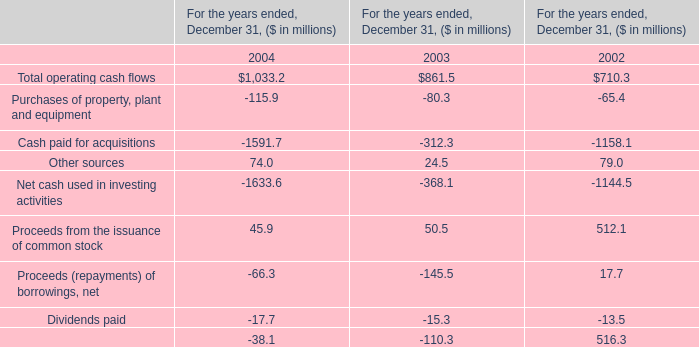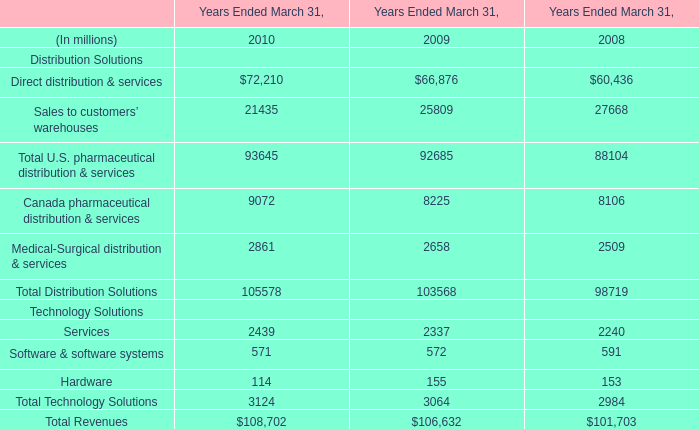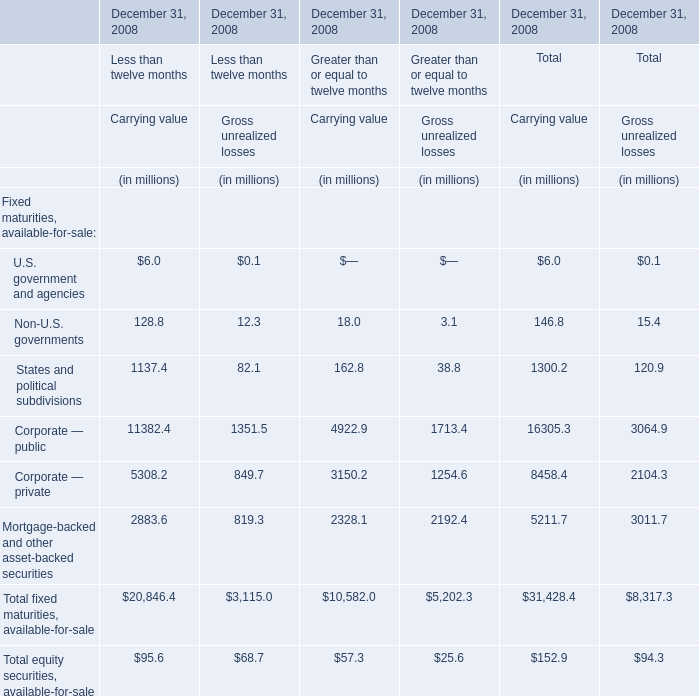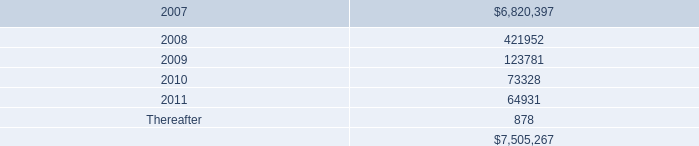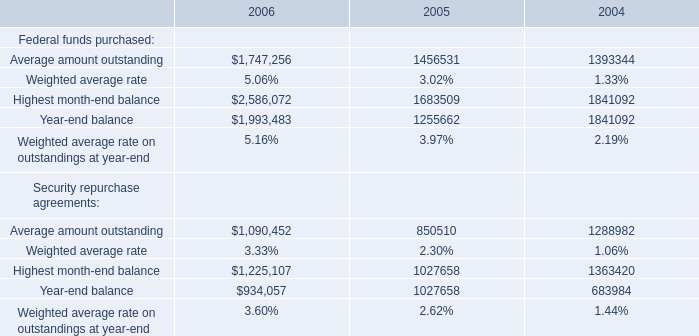How many kinds of Carrying value are greater than 10000 in 2008 for Less than twelve months? 
Answer: 1. 